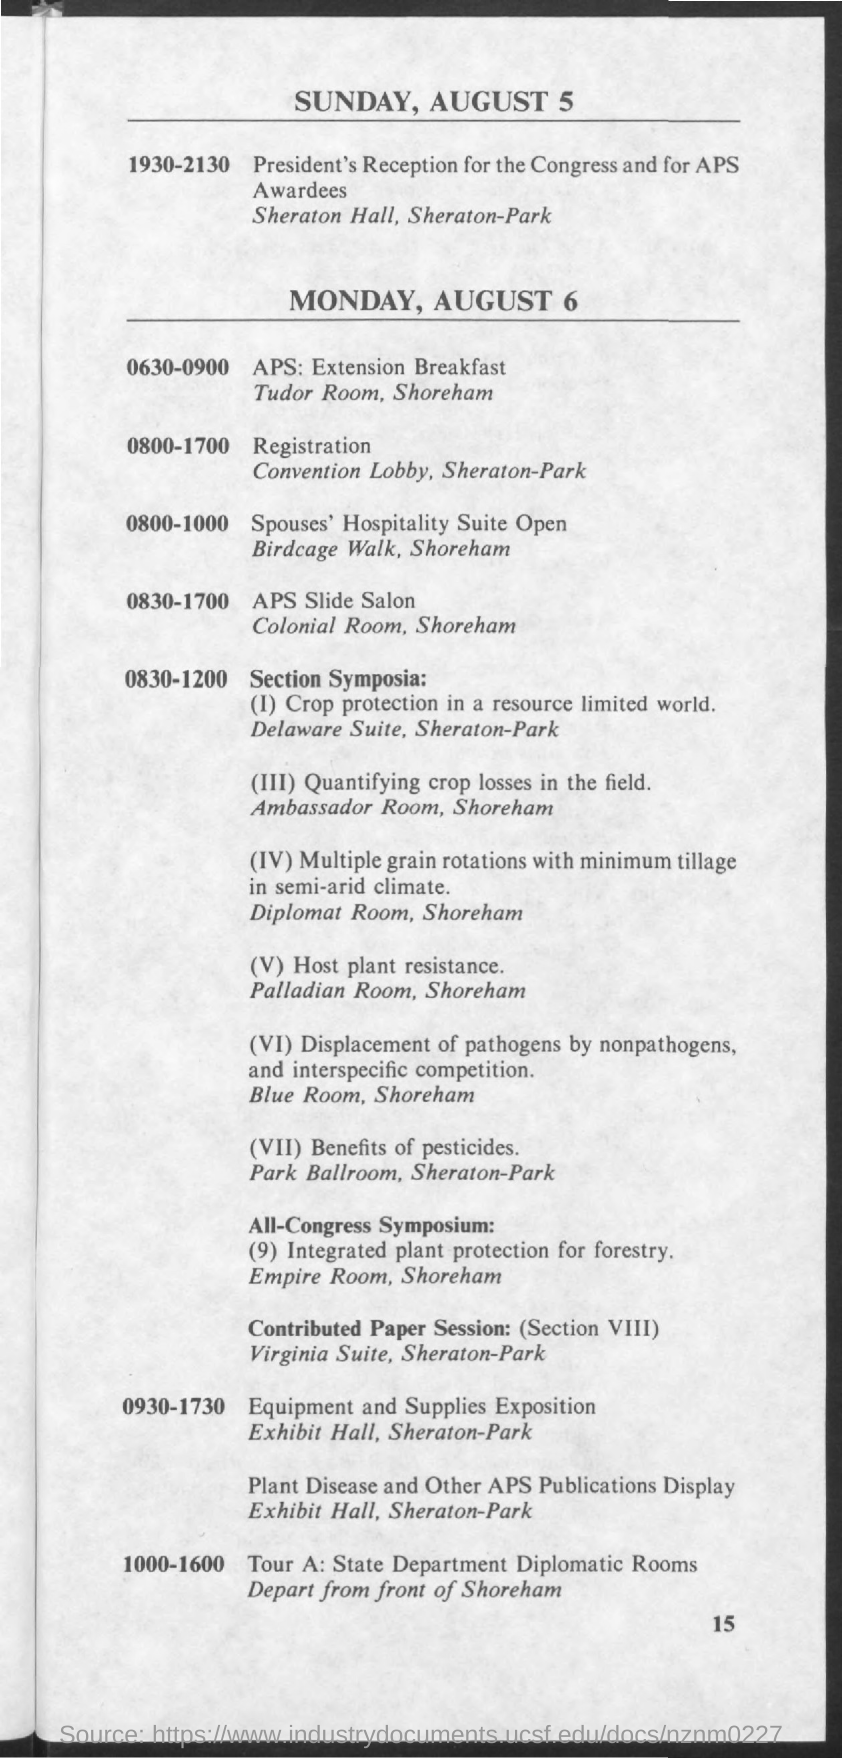Highlight a few significant elements in this photo. On Sunday, August 5, from 7:30 PM to 9:30 PM, there will be a president's reception for Congress and APS awardees. The schedule from 0800 to 1700 on Monday, August 6, 2023 is as follows: registration. 